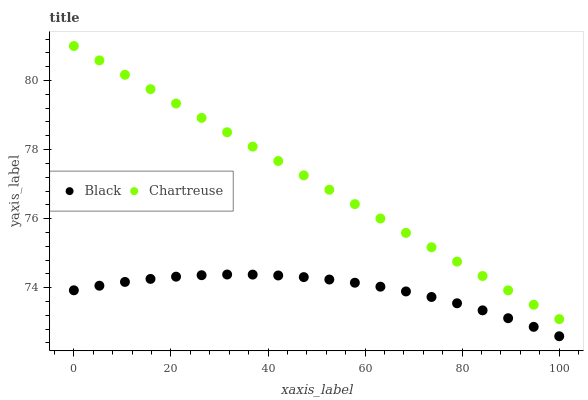Does Black have the minimum area under the curve?
Answer yes or no. Yes. Does Chartreuse have the maximum area under the curve?
Answer yes or no. Yes. Does Black have the maximum area under the curve?
Answer yes or no. No. Is Chartreuse the smoothest?
Answer yes or no. Yes. Is Black the roughest?
Answer yes or no. Yes. Is Black the smoothest?
Answer yes or no. No. Does Black have the lowest value?
Answer yes or no. Yes. Does Chartreuse have the highest value?
Answer yes or no. Yes. Does Black have the highest value?
Answer yes or no. No. Is Black less than Chartreuse?
Answer yes or no. Yes. Is Chartreuse greater than Black?
Answer yes or no. Yes. Does Black intersect Chartreuse?
Answer yes or no. No. 